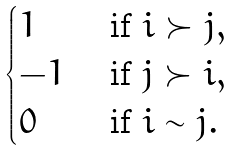<formula> <loc_0><loc_0><loc_500><loc_500>\begin{cases} 1 & \text { if } i \succ j , \\ - 1 & \text { if } j \succ i , \\ 0 & \text { if } i \sim j . \end{cases}</formula> 